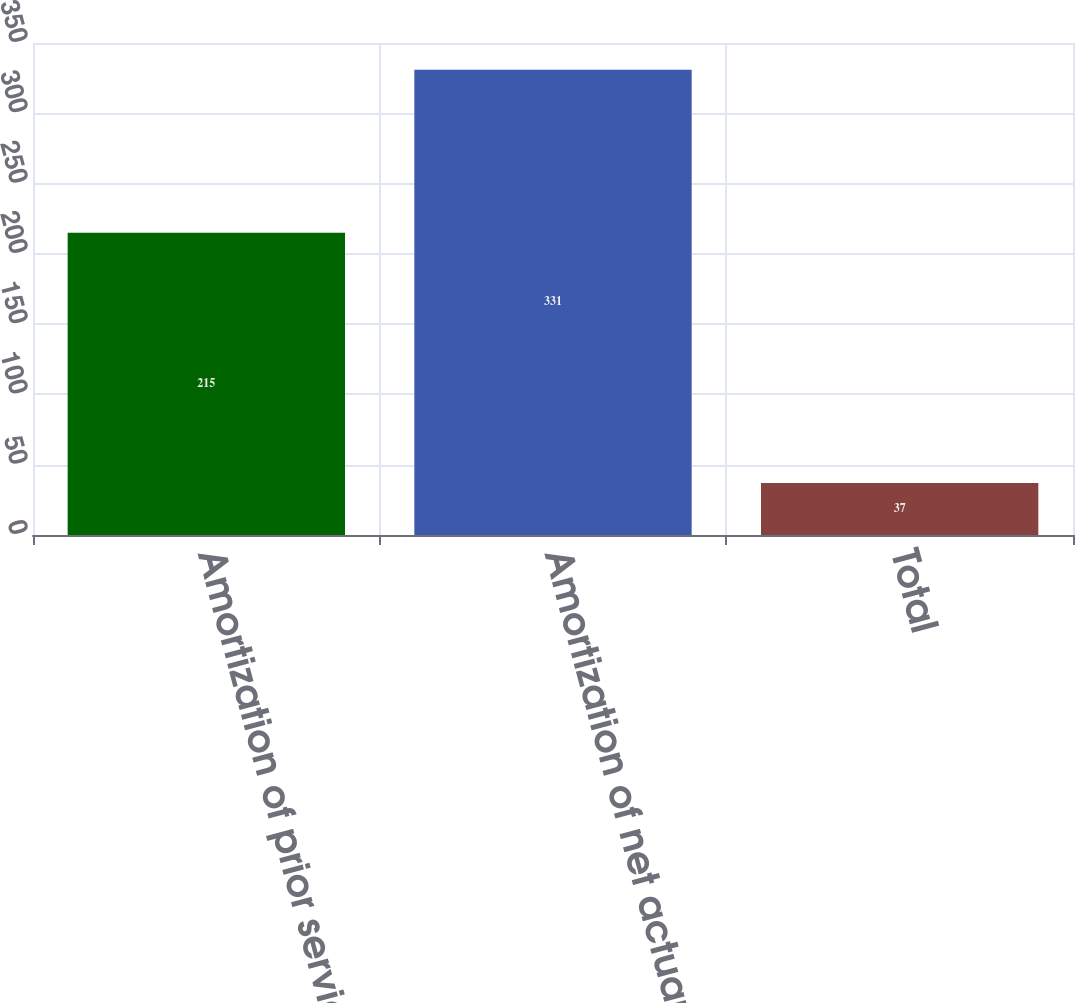Convert chart to OTSL. <chart><loc_0><loc_0><loc_500><loc_500><bar_chart><fcel>Amortization of prior service<fcel>Amortization of net actuarial<fcel>Total<nl><fcel>215<fcel>331<fcel>37<nl></chart> 